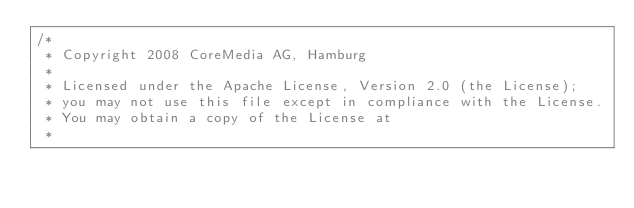<code> <loc_0><loc_0><loc_500><loc_500><_Java_>/*  
 * Copyright 2008 CoreMedia AG, Hamburg
 *
 * Licensed under the Apache License, Version 2.0 (the License); 
 * you may not use this file except in compliance with the License. 
 * You may obtain a copy of the License at 
 * </code> 